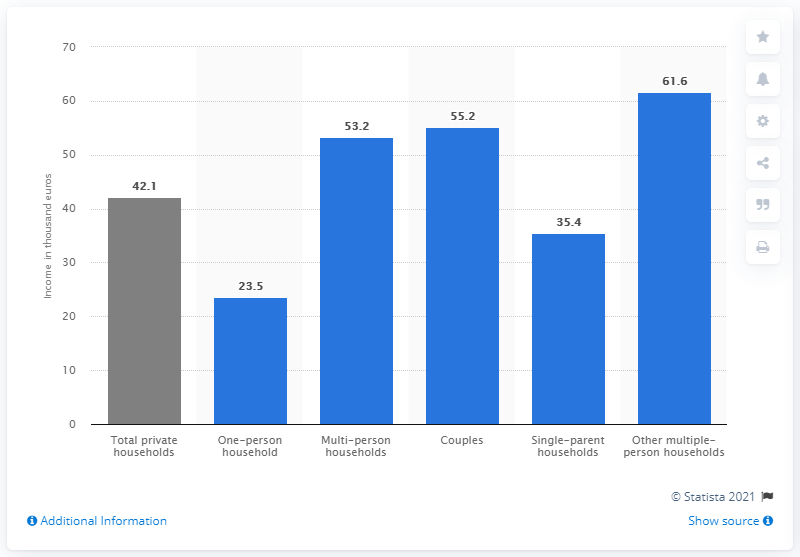Highlight a few significant elements in this photo. The question asks if the sum of the leftmost two bars is greater than the largest bar. The color of the leftmost bar is gray. 